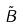Convert formula to latex. <formula><loc_0><loc_0><loc_500><loc_500>\tilde { B }</formula> 